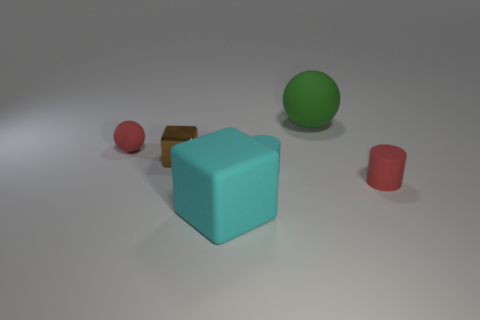Add 3 big cyan matte cubes. How many objects exist? 9 Subtract all spheres. How many objects are left? 4 Subtract all tiny purple rubber blocks. Subtract all brown blocks. How many objects are left? 5 Add 5 cylinders. How many cylinders are left? 7 Add 2 matte balls. How many matte balls exist? 4 Subtract 0 purple cubes. How many objects are left? 6 